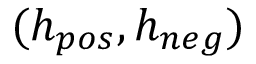<formula> <loc_0><loc_0><loc_500><loc_500>( h _ { p o s } , h _ { n e g } )</formula> 